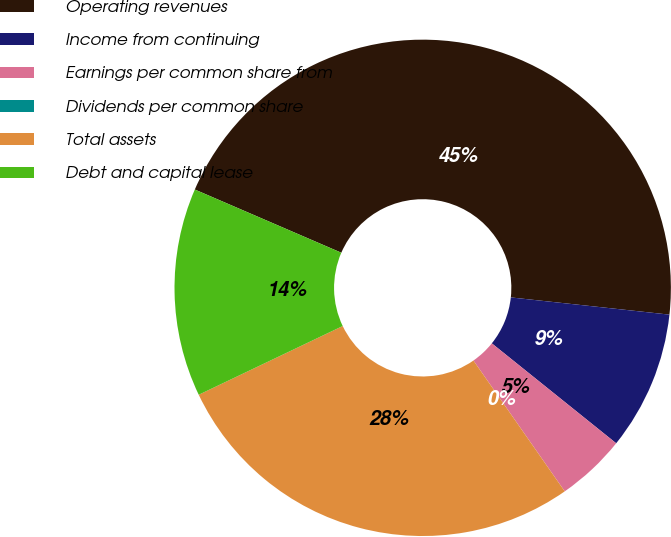Convert chart. <chart><loc_0><loc_0><loc_500><loc_500><pie_chart><fcel>Operating revenues<fcel>Income from continuing<fcel>Earnings per common share from<fcel>Dividends per common share<fcel>Total assets<fcel>Debt and capital lease<nl><fcel>45.24%<fcel>9.05%<fcel>4.53%<fcel>0.0%<fcel>27.61%<fcel>13.57%<nl></chart> 